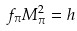<formula> <loc_0><loc_0><loc_500><loc_500>f _ { \pi } M ^ { 2 } _ { \pi } = h</formula> 